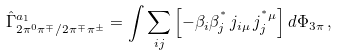Convert formula to latex. <formula><loc_0><loc_0><loc_500><loc_500>\hat { \Gamma } ^ { a _ { 1 } } _ { 2 \pi ^ { 0 } \pi ^ { \mp } / 2 \pi ^ { \mp } \pi ^ { \pm } } = \int \sum _ { i j } \left [ - \beta _ { i } \beta _ { j } ^ { ^ { * } } \, j _ { i \mu } \, j _ { j } ^ { ^ { * } \mu } \right ] d \Phi _ { 3 \pi } \, ,</formula> 